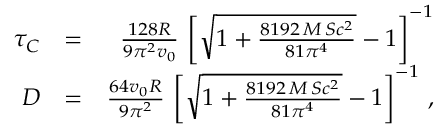<formula> <loc_0><loc_0><loc_500><loc_500>\begin{array} { r l r } { \tau _ { C } } & { = } & { { \frac { 1 2 8 R } { 9 \pi ^ { 2 } v _ { 0 } } } \, \left [ \sqrt { 1 + { \frac { 8 1 9 2 \, M \, S c ^ { 2 } } { 8 1 \pi ^ { 4 } } } } - 1 \right ] ^ { - 1 } } \\ { D } & { = } & { { \frac { 6 4 v _ { 0 } R } { 9 \pi ^ { 2 } } } \, \left [ \sqrt { 1 + { \frac { 8 1 9 2 \, M \, S c ^ { 2 } } { 8 1 \pi ^ { 4 } } } } - 1 \right ] ^ { - 1 } \, , } \end{array}</formula> 